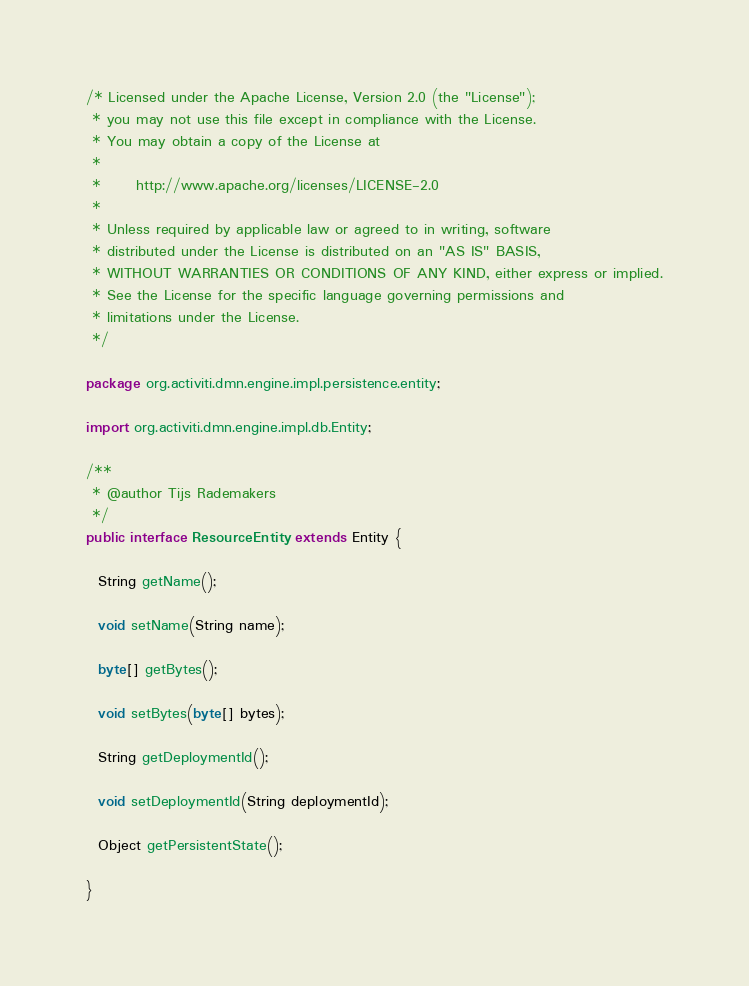Convert code to text. <code><loc_0><loc_0><loc_500><loc_500><_Java_>/* Licensed under the Apache License, Version 2.0 (the "License");
 * you may not use this file except in compliance with the License.
 * You may obtain a copy of the License at
 * 
 *      http://www.apache.org/licenses/LICENSE-2.0
 * 
 * Unless required by applicable law or agreed to in writing, software
 * distributed under the License is distributed on an "AS IS" BASIS,
 * WITHOUT WARRANTIES OR CONDITIONS OF ANY KIND, either express or implied.
 * See the License for the specific language governing permissions and
 * limitations under the License.
 */

package org.activiti.dmn.engine.impl.persistence.entity;

import org.activiti.dmn.engine.impl.db.Entity;

/**
 * @author Tijs Rademakers
 */
public interface ResourceEntity extends Entity {

  String getName();

  void setName(String name);

  byte[] getBytes();

  void setBytes(byte[] bytes);

  String getDeploymentId();

  void setDeploymentId(String deploymentId);

  Object getPersistentState();

}
</code> 